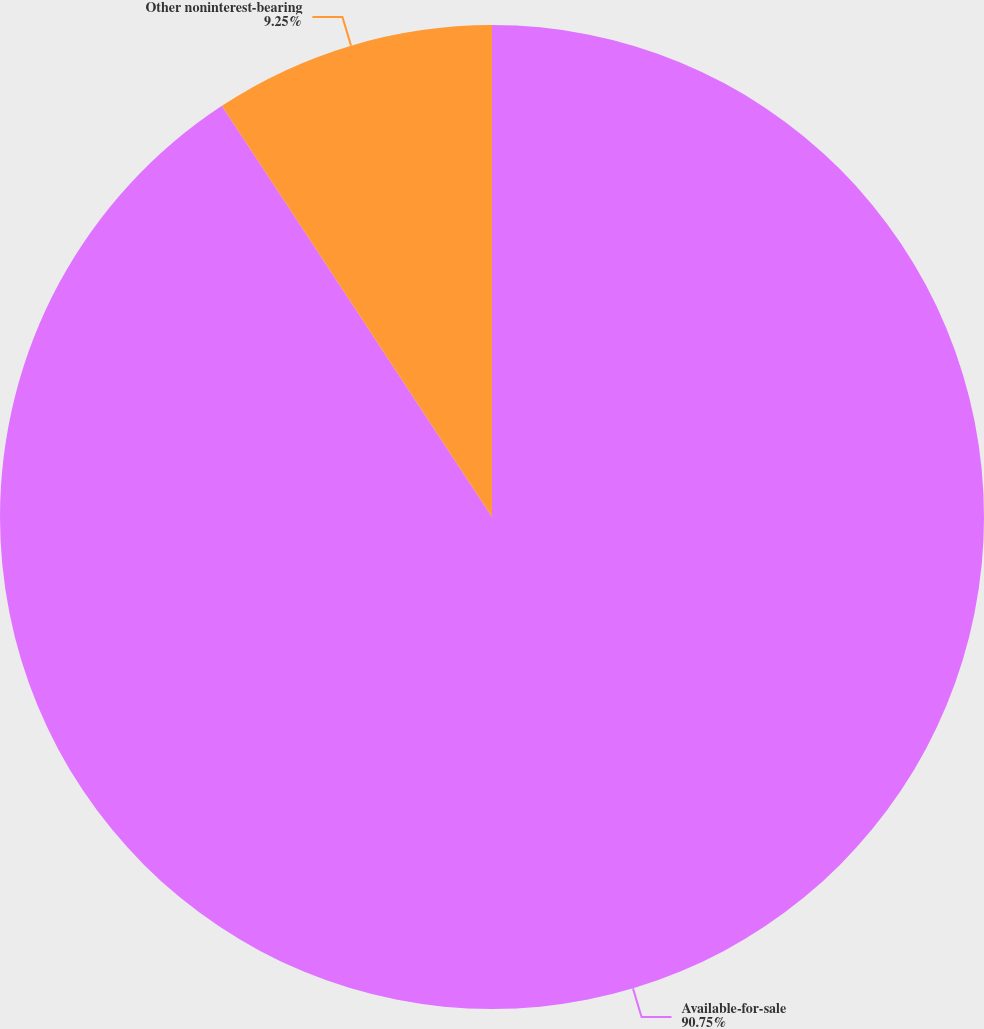Convert chart. <chart><loc_0><loc_0><loc_500><loc_500><pie_chart><fcel>Available-for-sale<fcel>Other noninterest-bearing<nl><fcel>90.75%<fcel>9.25%<nl></chart> 